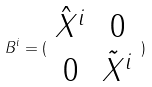<formula> <loc_0><loc_0><loc_500><loc_500>B ^ { i } = ( \begin{array} { c c } \hat { X } ^ { i } & 0 \\ 0 & \tilde { X } ^ { i } \end{array} )</formula> 